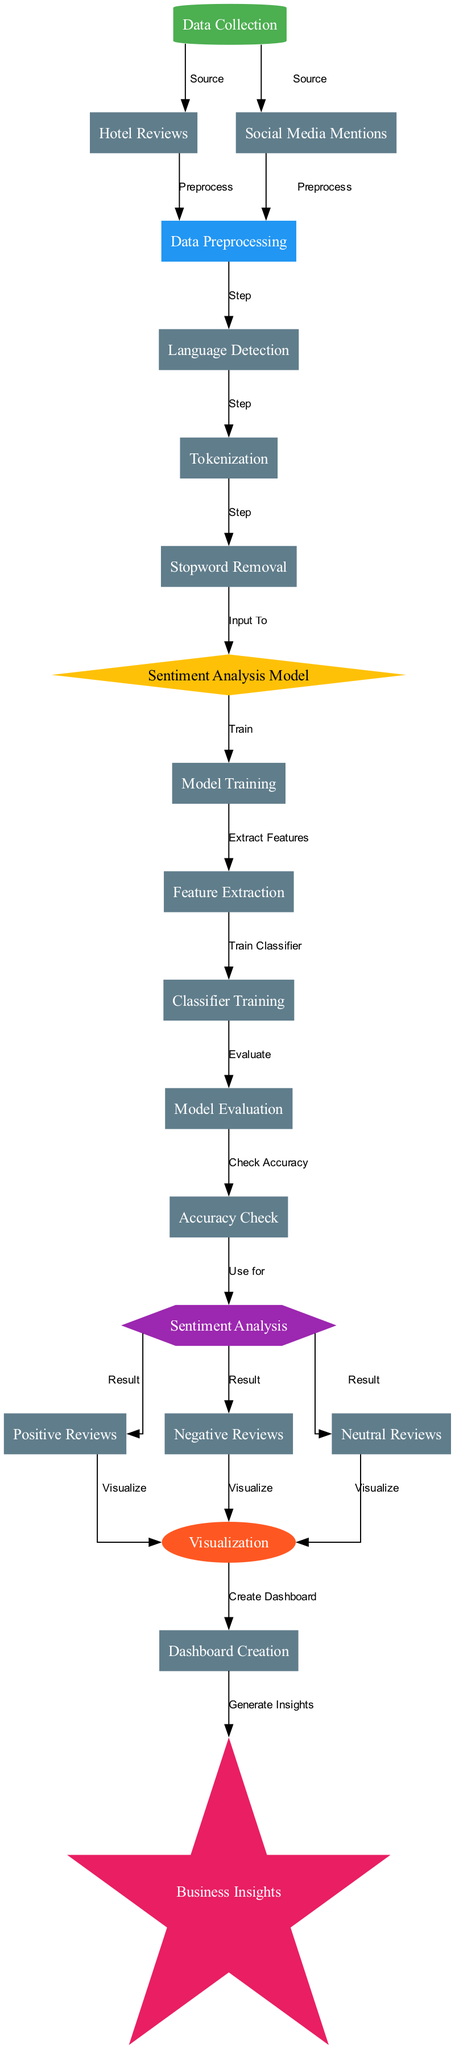What are the two sources of data collection? The diagram indicates that data is collected from "Hotel Reviews" and "Social Media Mentions". This is seen at the edges connecting the "data_collection" node to both of these nodes.
Answer: Hotel Reviews, Social Media Mentions How many nodes are there in the diagram? By counting all the unique nodes listed in the diagram, there are 17 distinct nodes present, each representing a different step or component in the flow of sentiment analysis.
Answer: 17 What is the first step after data preprocessing? The first step after the "preprocessing" node is "language_detection", as shown by the directed edge leading from "preprocessing" to "language_detection".
Answer: Language Detection Which node leads to model evaluation? The "classifier_training" node connects to the "model_evaluation" node, indicating that the output from training the classifier is utilized in the evaluation phase. This connection is clearly indicated by the directed edge in the diagram.
Answer: Classifier Training How many types of reviews are produced by sentiment analysis? The "sentiment_analysis" node branches out to three distinct types of reviews: "Positive Reviews", "Negative Reviews", and "Neutral Reviews". This can be observed from the edges diverging from the "sentiment_analysis" node.
Answer: Three What process follows the accuracy check? Following the "accuracy_check" node, the next process utilizes the evaluated model for "sentiment_analysis", indicating that accuracy checks are integral before proceeding to the analysis stage. This relationship is outlined in the flow of the diagram.
Answer: Sentiment Analysis What does the visualization node receive input from? The "visualization" node receives inputs from all three types of reviews: "positive_reviews", "negative_reviews", and "neutral_reviews", shown by the edges leading into the "visualization" node from these review type nodes.
Answer: Positive Reviews, Negative Reviews, Neutral Reviews What is the final output of the entire process? The final output of the entire process is "Business Insights", which is generated after "Dashboard Creation", as indicated by the directed edge from "dashboard_creation" to "business_insights".
Answer: Business Insights 